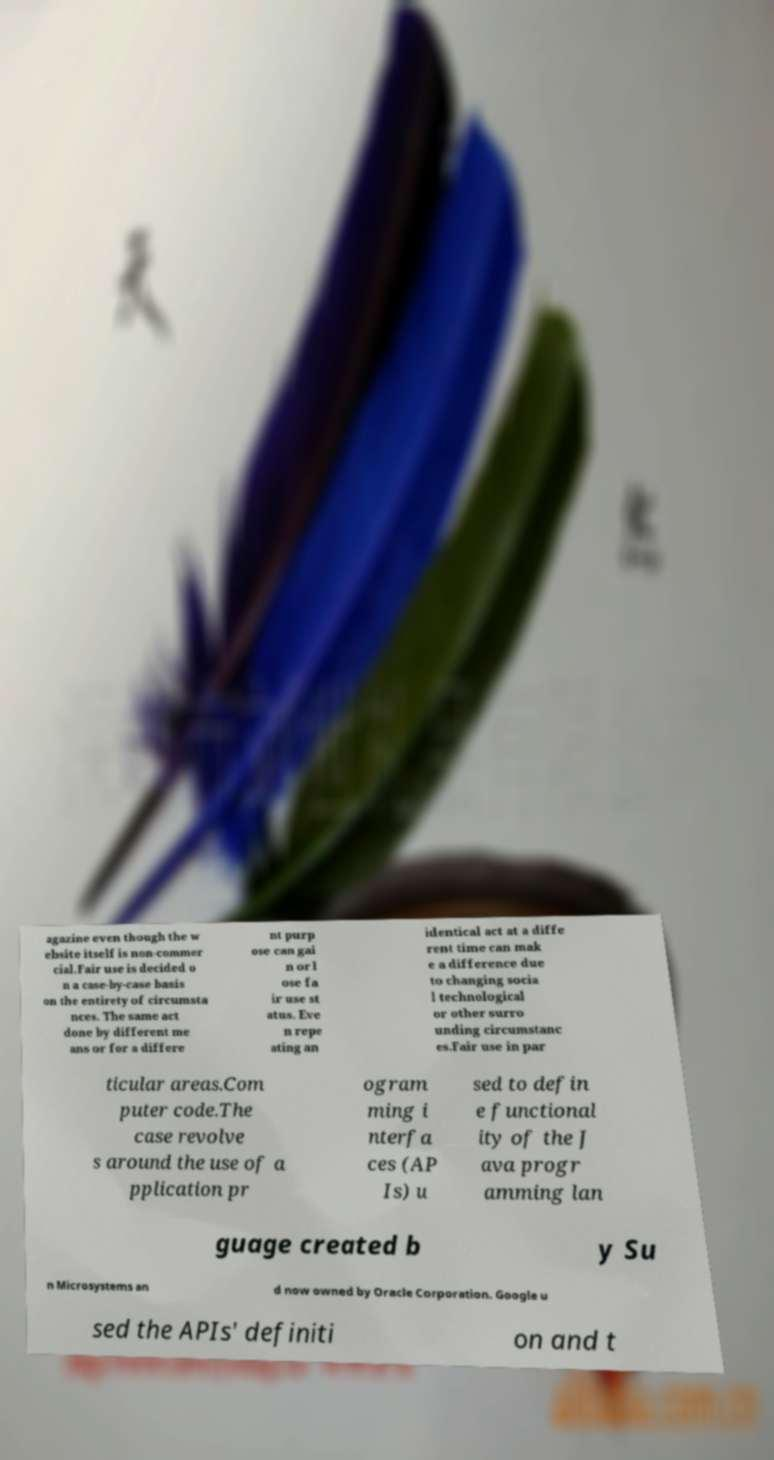What messages or text are displayed in this image? I need them in a readable, typed format. agazine even though the w ebsite itself is non-commer cial.Fair use is decided o n a case-by-case basis on the entirety of circumsta nces. The same act done by different me ans or for a differe nt purp ose can gai n or l ose fa ir use st atus. Eve n repe ating an identical act at a diffe rent time can mak e a difference due to changing socia l technological or other surro unding circumstanc es.Fair use in par ticular areas.Com puter code.The case revolve s around the use of a pplication pr ogram ming i nterfa ces (AP Is) u sed to defin e functional ity of the J ava progr amming lan guage created b y Su n Microsystems an d now owned by Oracle Corporation. Google u sed the APIs' definiti on and t 